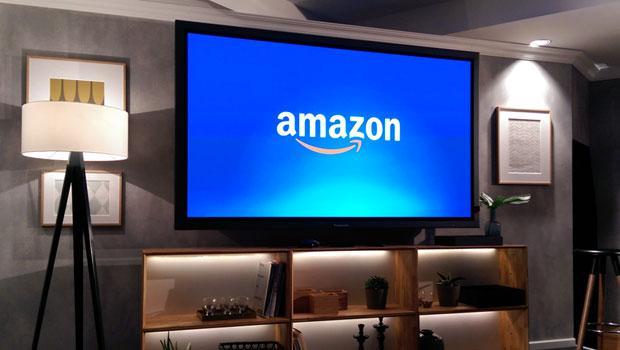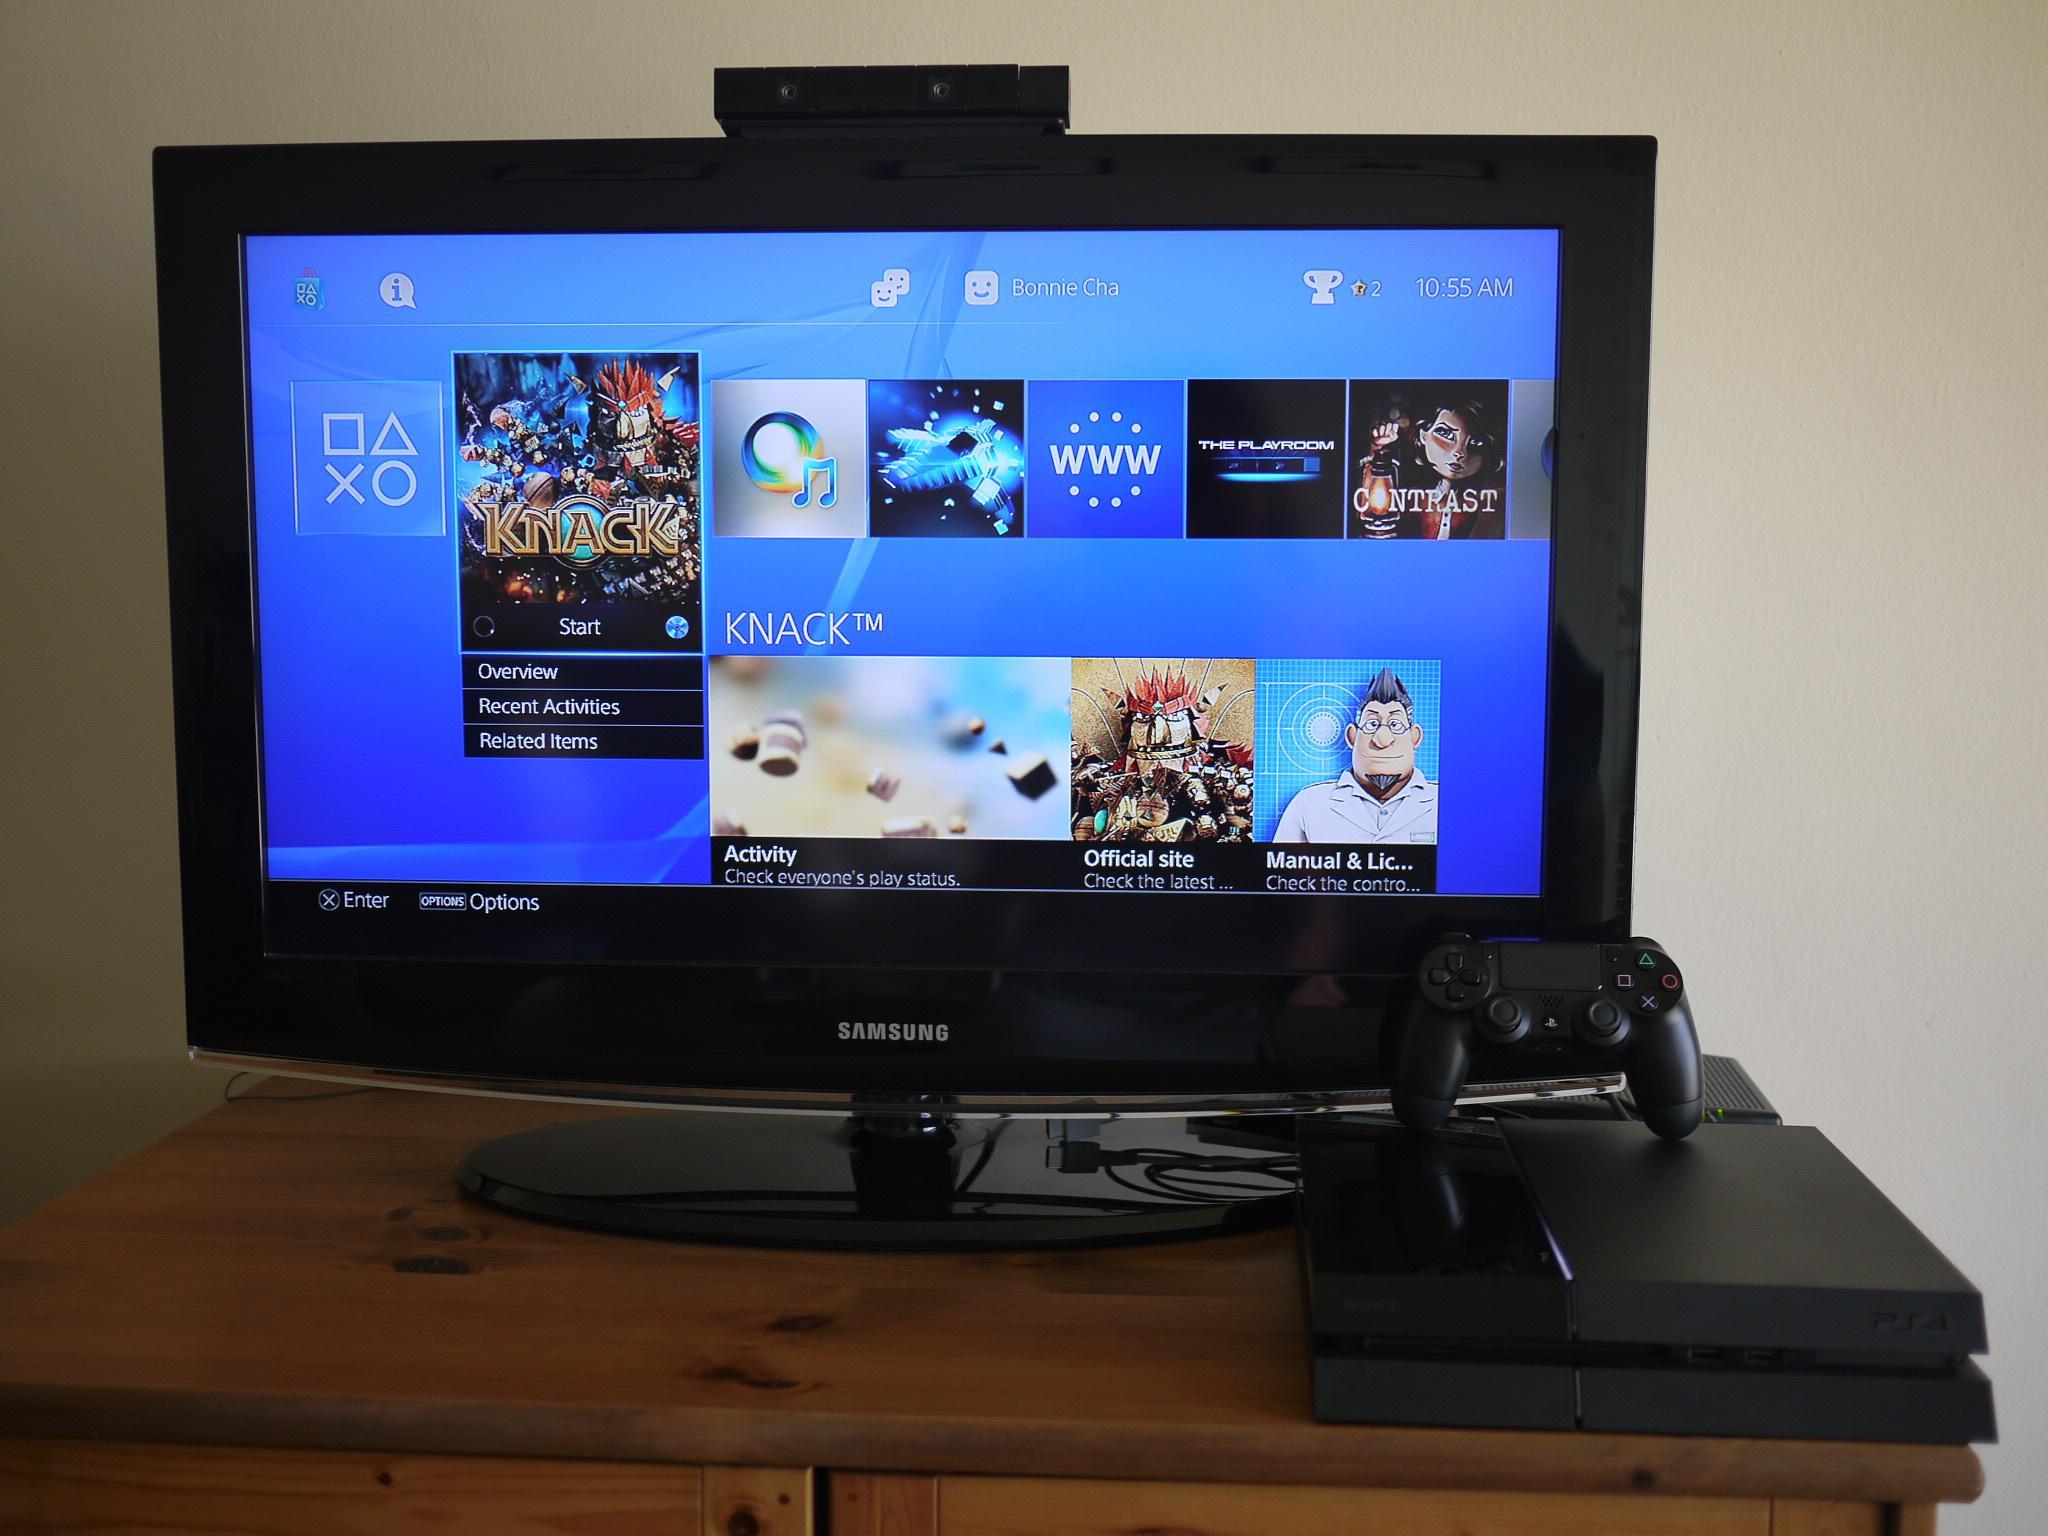The first image is the image on the left, the second image is the image on the right. Given the left and right images, does the statement "Each image shows one wide screen on a wall, with seating in front of it, and one image shows a screen surrounded by a blue glow." hold true? Answer yes or no. No. 